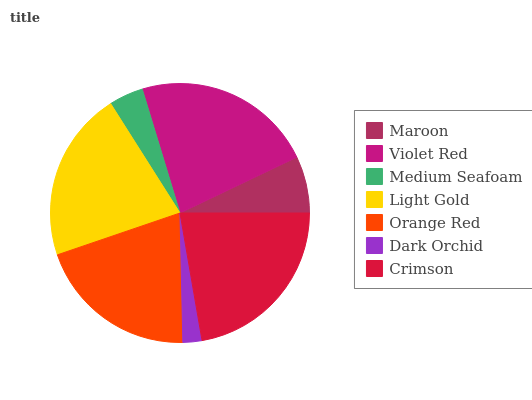Is Dark Orchid the minimum?
Answer yes or no. Yes. Is Violet Red the maximum?
Answer yes or no. Yes. Is Medium Seafoam the minimum?
Answer yes or no. No. Is Medium Seafoam the maximum?
Answer yes or no. No. Is Violet Red greater than Medium Seafoam?
Answer yes or no. Yes. Is Medium Seafoam less than Violet Red?
Answer yes or no. Yes. Is Medium Seafoam greater than Violet Red?
Answer yes or no. No. Is Violet Red less than Medium Seafoam?
Answer yes or no. No. Is Orange Red the high median?
Answer yes or no. Yes. Is Orange Red the low median?
Answer yes or no. Yes. Is Maroon the high median?
Answer yes or no. No. Is Light Gold the low median?
Answer yes or no. No. 